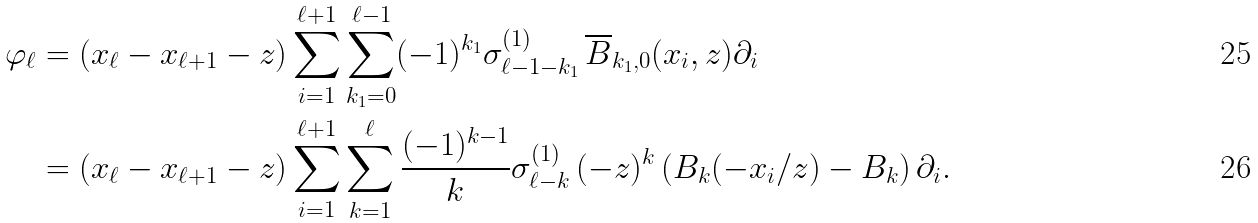Convert formula to latex. <formula><loc_0><loc_0><loc_500><loc_500>\varphi _ { \ell } & = ( x _ { \ell } - x _ { \ell + 1 } - z ) \sum _ { i = 1 } ^ { \ell + 1 } \sum _ { k _ { 1 } = 0 } ^ { \ell - 1 } ( - 1 ) ^ { k _ { 1 } } \sigma _ { \ell - 1 - k _ { 1 } } ^ { ( 1 ) } \, \overline { B } _ { k _ { 1 } , 0 } ( x _ { i } , z ) \partial _ { i } \\ & = ( x _ { \ell } - x _ { \ell + 1 } - z ) \sum _ { i = 1 } ^ { \ell + 1 } \sum _ { k = 1 } ^ { \ell } \frac { ( - 1 ) ^ { k - 1 } } { k } \sigma _ { \ell - k } ^ { ( 1 ) } \, ( - z ) ^ { k } \left ( B _ { k } ( - x _ { i } / z ) - B _ { k } \right ) \partial _ { i } .</formula> 